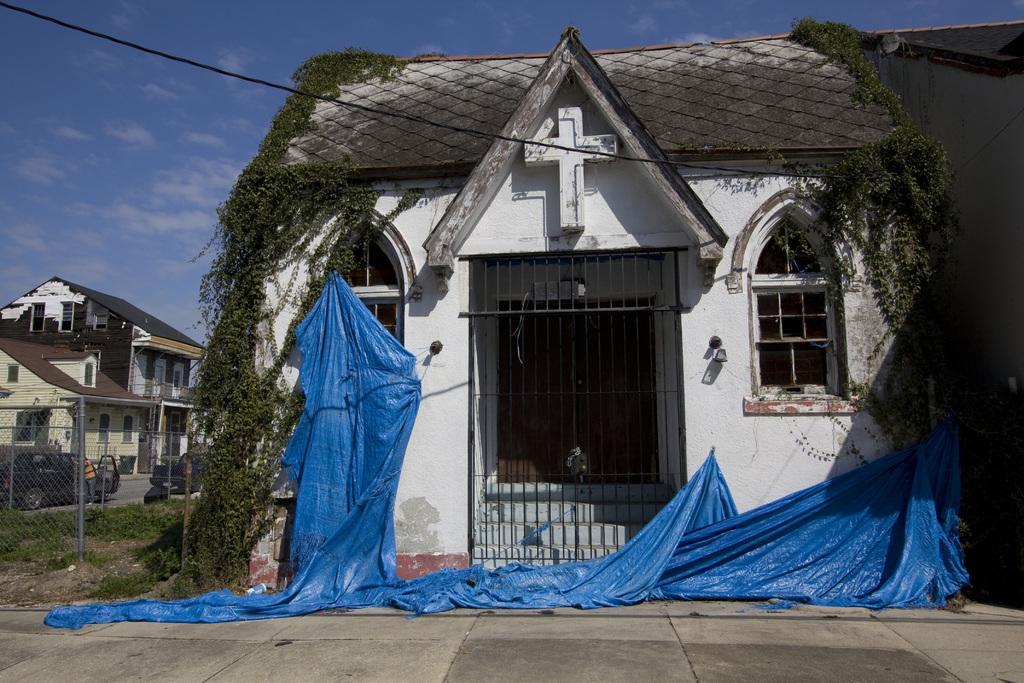In one or two sentences, can you explain what this image depicts? In this image we can see a house with roof, windows, a door, gate, a staircase and a cross on it. We can also see some plants and a tarpaulin on the ground. On the left side we can see some houses, vehicles on the road, grass, a metal fence, a wire and the sky which looks cloudy. 